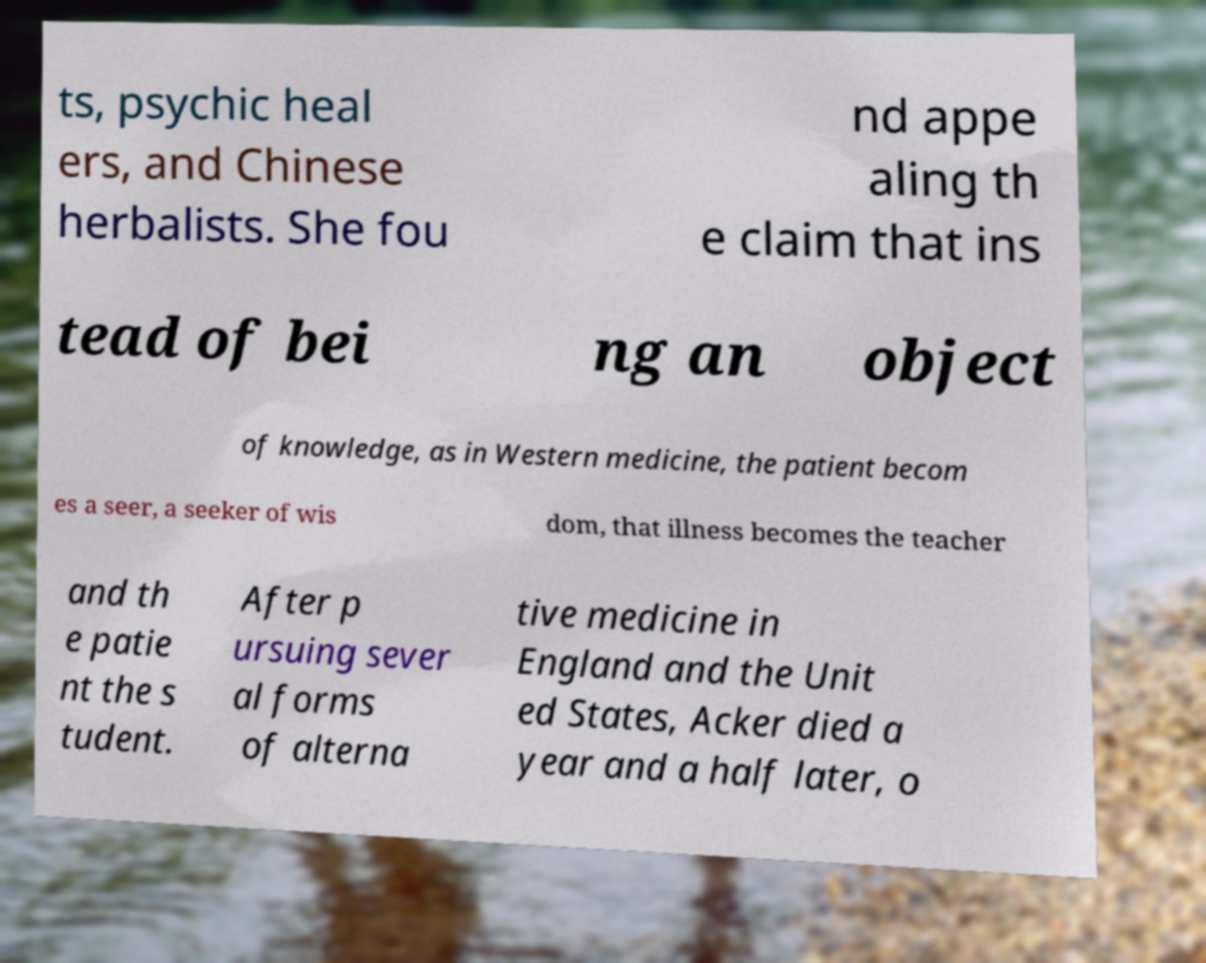Could you extract and type out the text from this image? ts, psychic heal ers, and Chinese herbalists. She fou nd appe aling th e claim that ins tead of bei ng an object of knowledge, as in Western medicine, the patient becom es a seer, a seeker of wis dom, that illness becomes the teacher and th e patie nt the s tudent. After p ursuing sever al forms of alterna tive medicine in England and the Unit ed States, Acker died a year and a half later, o 